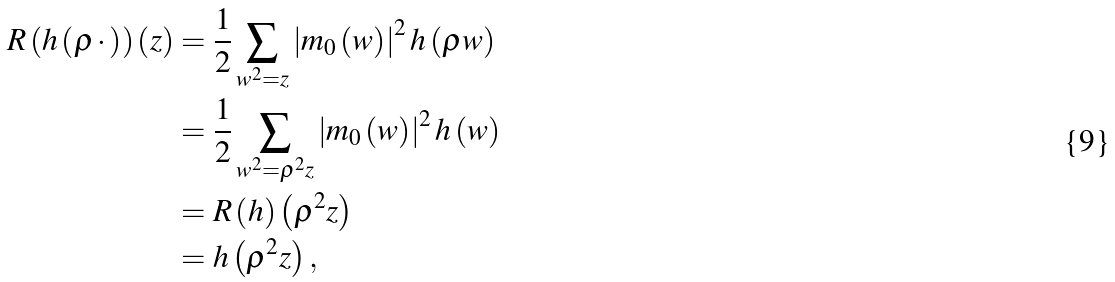<formula> <loc_0><loc_0><loc_500><loc_500>R \left ( h \left ( \rho \, \cdot \, \right ) \right ) \left ( z \right ) & = \frac { 1 } { 2 } \sum _ { w ^ { 2 } = z } \left | m _ { 0 } \left ( w \right ) \right | ^ { 2 } h \left ( \rho w \right ) \\ & = \frac { 1 } { 2 } \sum _ { w ^ { 2 } = \rho ^ { 2 } z } \left | m _ { 0 } \left ( w \right ) \right | ^ { 2 } h \left ( w \right ) \\ & = R \left ( h \right ) \left ( \rho ^ { 2 } z \right ) \\ & = h \left ( \rho ^ { 2 } z \right ) ,</formula> 